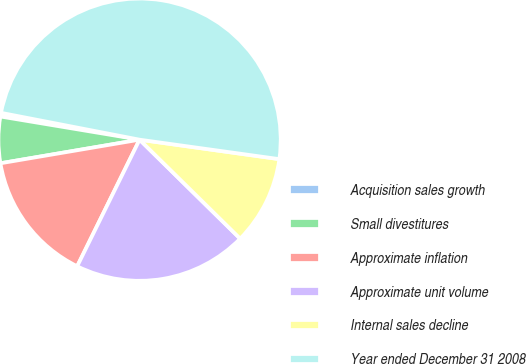Convert chart. <chart><loc_0><loc_0><loc_500><loc_500><pie_chart><fcel>Acquisition sales growth<fcel>Small divestitures<fcel>Approximate inflation<fcel>Approximate unit volume<fcel>Internal sales decline<fcel>Year ended December 31 2008<nl><fcel>0.42%<fcel>5.3%<fcel>15.04%<fcel>19.92%<fcel>10.17%<fcel>49.16%<nl></chart> 